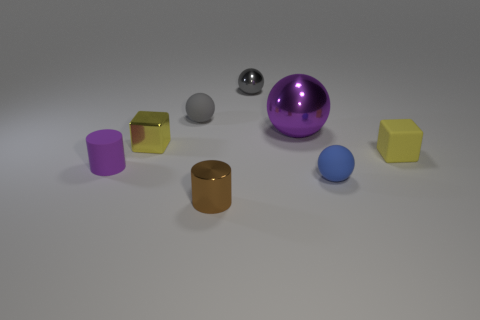How many things are either large yellow metal blocks or yellow rubber blocks that are behind the small brown cylinder?
Offer a terse response. 1. Is the number of tiny blue objects that are behind the gray metallic thing greater than the number of matte cubes?
Make the answer very short. No. Are there an equal number of yellow objects left of the blue rubber ball and gray balls that are to the left of the tiny yellow shiny cube?
Your response must be concise. No. There is a yellow block that is on the right side of the blue rubber thing; is there a yellow shiny block that is on the right side of it?
Make the answer very short. No. The yellow shiny object has what shape?
Your answer should be compact. Cube. The other cube that is the same color as the matte block is what size?
Provide a short and direct response. Small. There is a yellow thing left of the matte ball that is right of the small gray metal ball; what is its size?
Your answer should be very brief. Small. There is a matte sphere in front of the big metal thing; how big is it?
Keep it short and to the point. Small. Are there fewer big metallic objects that are to the left of the small matte cylinder than tiny purple matte objects on the right side of the small shiny ball?
Your answer should be very brief. No. The matte cube is what color?
Provide a succinct answer. Yellow. 